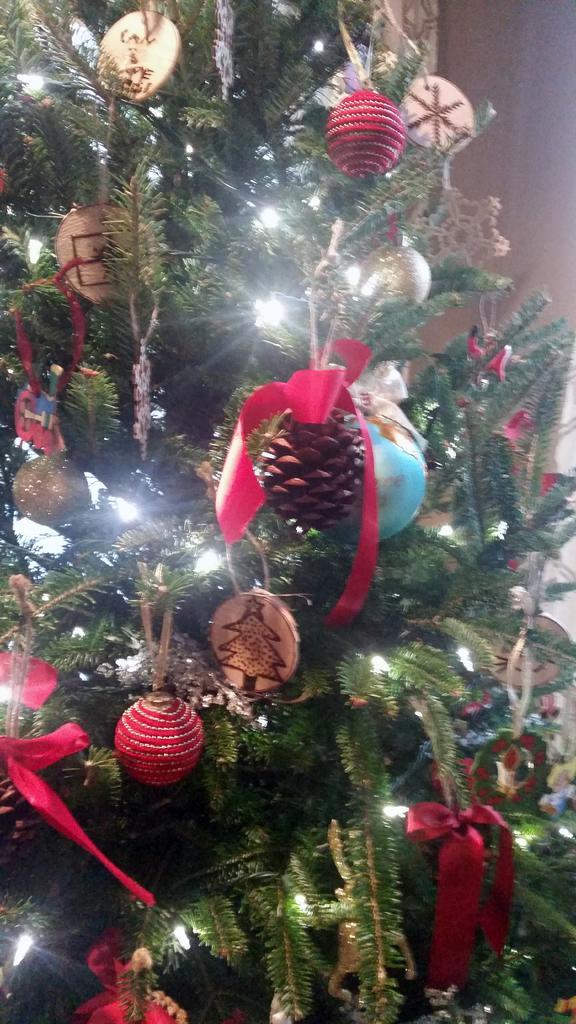In one or two sentences, can you explain what this image depicts? The picture consists of a decorated christmas tree, on a tree there are lights, ribbons and other objects. 